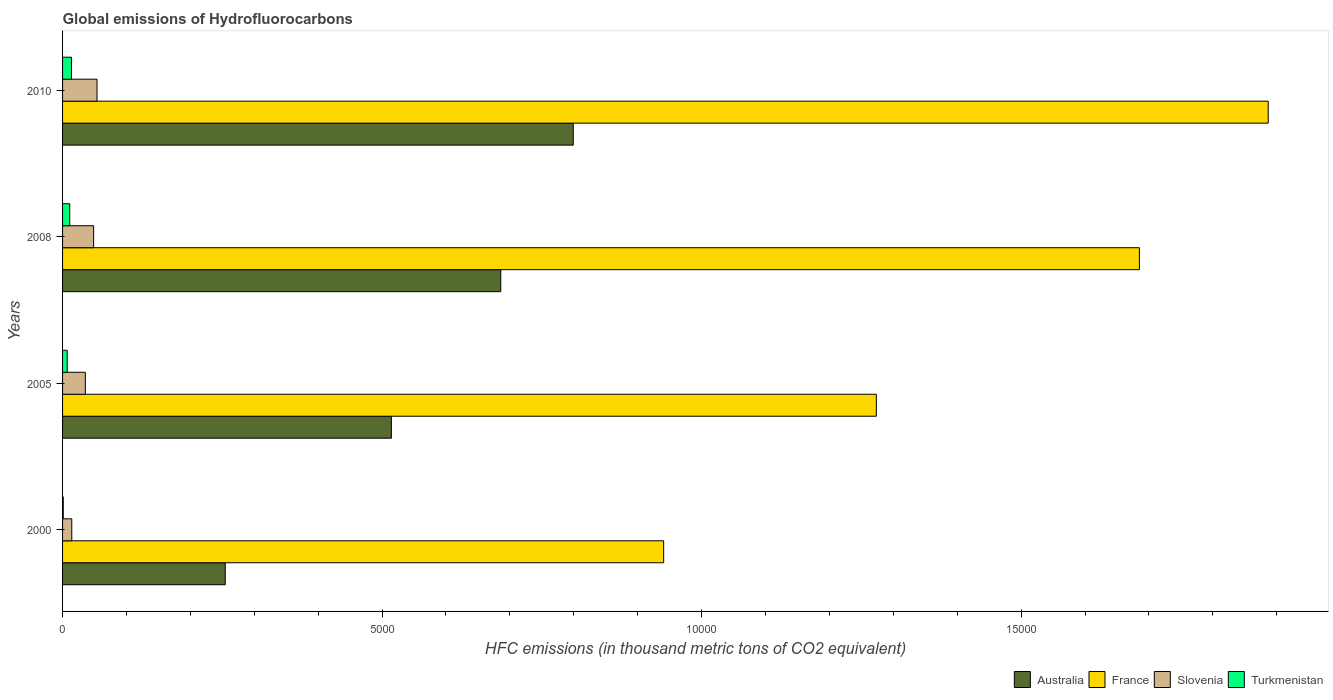Are the number of bars per tick equal to the number of legend labels?
Make the answer very short. Yes. What is the label of the 3rd group of bars from the top?
Provide a short and direct response. 2005. Across all years, what is the maximum global emissions of Hydrofluorocarbons in Australia?
Your answer should be compact. 7992. Across all years, what is the minimum global emissions of Hydrofluorocarbons in Australia?
Provide a short and direct response. 2545.7. In which year was the global emissions of Hydrofluorocarbons in Slovenia maximum?
Provide a succinct answer. 2010. What is the total global emissions of Hydrofluorocarbons in Australia in the graph?
Your answer should be very brief. 2.25e+04. What is the difference between the global emissions of Hydrofluorocarbons in France in 2005 and that in 2008?
Provide a succinct answer. -4116.4. What is the difference between the global emissions of Hydrofluorocarbons in Australia in 2005 and the global emissions of Hydrofluorocarbons in Slovenia in 2008?
Offer a terse response. 4659.6. What is the average global emissions of Hydrofluorocarbons in Australia per year?
Make the answer very short. 5635.18. In the year 2008, what is the difference between the global emissions of Hydrofluorocarbons in Slovenia and global emissions of Hydrofluorocarbons in Turkmenistan?
Ensure brevity in your answer.  373.8. What is the ratio of the global emissions of Hydrofluorocarbons in Turkmenistan in 2005 to that in 2008?
Your answer should be compact. 0.65. Is the difference between the global emissions of Hydrofluorocarbons in Slovenia in 2005 and 2010 greater than the difference between the global emissions of Hydrofluorocarbons in Turkmenistan in 2005 and 2010?
Your response must be concise. No. What is the difference between the highest and the second highest global emissions of Hydrofluorocarbons in France?
Ensure brevity in your answer.  2015.9. What is the difference between the highest and the lowest global emissions of Hydrofluorocarbons in France?
Make the answer very short. 9460.6. What does the 2nd bar from the top in 2010 represents?
Your answer should be very brief. Slovenia. How many bars are there?
Your answer should be very brief. 16. Are all the bars in the graph horizontal?
Your answer should be compact. Yes. How many years are there in the graph?
Provide a short and direct response. 4. What is the difference between two consecutive major ticks on the X-axis?
Offer a terse response. 5000. Are the values on the major ticks of X-axis written in scientific E-notation?
Ensure brevity in your answer.  No. Does the graph contain any zero values?
Ensure brevity in your answer.  No. Does the graph contain grids?
Your answer should be compact. No. How are the legend labels stacked?
Give a very brief answer. Horizontal. What is the title of the graph?
Your response must be concise. Global emissions of Hydrofluorocarbons. Does "East Asia (all income levels)" appear as one of the legend labels in the graph?
Offer a very short reply. No. What is the label or title of the X-axis?
Keep it short and to the point. HFC emissions (in thousand metric tons of CO2 equivalent). What is the HFC emissions (in thousand metric tons of CO2 equivalent) of Australia in 2000?
Provide a short and direct response. 2545.7. What is the HFC emissions (in thousand metric tons of CO2 equivalent) of France in 2000?
Your answer should be very brief. 9406.4. What is the HFC emissions (in thousand metric tons of CO2 equivalent) in Slovenia in 2000?
Provide a short and direct response. 144.1. What is the HFC emissions (in thousand metric tons of CO2 equivalent) in Turkmenistan in 2000?
Your response must be concise. 10.9. What is the HFC emissions (in thousand metric tons of CO2 equivalent) of Australia in 2005?
Give a very brief answer. 5145.6. What is the HFC emissions (in thousand metric tons of CO2 equivalent) of France in 2005?
Make the answer very short. 1.27e+04. What is the HFC emissions (in thousand metric tons of CO2 equivalent) in Slovenia in 2005?
Keep it short and to the point. 356.4. What is the HFC emissions (in thousand metric tons of CO2 equivalent) of Turkmenistan in 2005?
Keep it short and to the point. 72.9. What is the HFC emissions (in thousand metric tons of CO2 equivalent) of Australia in 2008?
Your answer should be very brief. 6857.4. What is the HFC emissions (in thousand metric tons of CO2 equivalent) in France in 2008?
Keep it short and to the point. 1.69e+04. What is the HFC emissions (in thousand metric tons of CO2 equivalent) of Slovenia in 2008?
Keep it short and to the point. 486. What is the HFC emissions (in thousand metric tons of CO2 equivalent) in Turkmenistan in 2008?
Give a very brief answer. 112.2. What is the HFC emissions (in thousand metric tons of CO2 equivalent) of Australia in 2010?
Ensure brevity in your answer.  7992. What is the HFC emissions (in thousand metric tons of CO2 equivalent) in France in 2010?
Provide a short and direct response. 1.89e+04. What is the HFC emissions (in thousand metric tons of CO2 equivalent) in Slovenia in 2010?
Your response must be concise. 539. What is the HFC emissions (in thousand metric tons of CO2 equivalent) in Turkmenistan in 2010?
Give a very brief answer. 139. Across all years, what is the maximum HFC emissions (in thousand metric tons of CO2 equivalent) in Australia?
Make the answer very short. 7992. Across all years, what is the maximum HFC emissions (in thousand metric tons of CO2 equivalent) in France?
Keep it short and to the point. 1.89e+04. Across all years, what is the maximum HFC emissions (in thousand metric tons of CO2 equivalent) of Slovenia?
Offer a very short reply. 539. Across all years, what is the maximum HFC emissions (in thousand metric tons of CO2 equivalent) in Turkmenistan?
Ensure brevity in your answer.  139. Across all years, what is the minimum HFC emissions (in thousand metric tons of CO2 equivalent) of Australia?
Give a very brief answer. 2545.7. Across all years, what is the minimum HFC emissions (in thousand metric tons of CO2 equivalent) in France?
Give a very brief answer. 9406.4. Across all years, what is the minimum HFC emissions (in thousand metric tons of CO2 equivalent) in Slovenia?
Offer a very short reply. 144.1. Across all years, what is the minimum HFC emissions (in thousand metric tons of CO2 equivalent) of Turkmenistan?
Make the answer very short. 10.9. What is the total HFC emissions (in thousand metric tons of CO2 equivalent) of Australia in the graph?
Give a very brief answer. 2.25e+04. What is the total HFC emissions (in thousand metric tons of CO2 equivalent) of France in the graph?
Keep it short and to the point. 5.79e+04. What is the total HFC emissions (in thousand metric tons of CO2 equivalent) of Slovenia in the graph?
Ensure brevity in your answer.  1525.5. What is the total HFC emissions (in thousand metric tons of CO2 equivalent) in Turkmenistan in the graph?
Your response must be concise. 335. What is the difference between the HFC emissions (in thousand metric tons of CO2 equivalent) in Australia in 2000 and that in 2005?
Make the answer very short. -2599.9. What is the difference between the HFC emissions (in thousand metric tons of CO2 equivalent) in France in 2000 and that in 2005?
Make the answer very short. -3328.3. What is the difference between the HFC emissions (in thousand metric tons of CO2 equivalent) of Slovenia in 2000 and that in 2005?
Make the answer very short. -212.3. What is the difference between the HFC emissions (in thousand metric tons of CO2 equivalent) of Turkmenistan in 2000 and that in 2005?
Your response must be concise. -62. What is the difference between the HFC emissions (in thousand metric tons of CO2 equivalent) of Australia in 2000 and that in 2008?
Provide a short and direct response. -4311.7. What is the difference between the HFC emissions (in thousand metric tons of CO2 equivalent) in France in 2000 and that in 2008?
Provide a short and direct response. -7444.7. What is the difference between the HFC emissions (in thousand metric tons of CO2 equivalent) in Slovenia in 2000 and that in 2008?
Make the answer very short. -341.9. What is the difference between the HFC emissions (in thousand metric tons of CO2 equivalent) in Turkmenistan in 2000 and that in 2008?
Offer a very short reply. -101.3. What is the difference between the HFC emissions (in thousand metric tons of CO2 equivalent) of Australia in 2000 and that in 2010?
Ensure brevity in your answer.  -5446.3. What is the difference between the HFC emissions (in thousand metric tons of CO2 equivalent) in France in 2000 and that in 2010?
Offer a very short reply. -9460.6. What is the difference between the HFC emissions (in thousand metric tons of CO2 equivalent) of Slovenia in 2000 and that in 2010?
Your answer should be very brief. -394.9. What is the difference between the HFC emissions (in thousand metric tons of CO2 equivalent) in Turkmenistan in 2000 and that in 2010?
Your answer should be very brief. -128.1. What is the difference between the HFC emissions (in thousand metric tons of CO2 equivalent) of Australia in 2005 and that in 2008?
Your answer should be very brief. -1711.8. What is the difference between the HFC emissions (in thousand metric tons of CO2 equivalent) of France in 2005 and that in 2008?
Ensure brevity in your answer.  -4116.4. What is the difference between the HFC emissions (in thousand metric tons of CO2 equivalent) in Slovenia in 2005 and that in 2008?
Ensure brevity in your answer.  -129.6. What is the difference between the HFC emissions (in thousand metric tons of CO2 equivalent) in Turkmenistan in 2005 and that in 2008?
Ensure brevity in your answer.  -39.3. What is the difference between the HFC emissions (in thousand metric tons of CO2 equivalent) in Australia in 2005 and that in 2010?
Give a very brief answer. -2846.4. What is the difference between the HFC emissions (in thousand metric tons of CO2 equivalent) of France in 2005 and that in 2010?
Provide a succinct answer. -6132.3. What is the difference between the HFC emissions (in thousand metric tons of CO2 equivalent) in Slovenia in 2005 and that in 2010?
Provide a short and direct response. -182.6. What is the difference between the HFC emissions (in thousand metric tons of CO2 equivalent) in Turkmenistan in 2005 and that in 2010?
Keep it short and to the point. -66.1. What is the difference between the HFC emissions (in thousand metric tons of CO2 equivalent) of Australia in 2008 and that in 2010?
Your response must be concise. -1134.6. What is the difference between the HFC emissions (in thousand metric tons of CO2 equivalent) of France in 2008 and that in 2010?
Offer a very short reply. -2015.9. What is the difference between the HFC emissions (in thousand metric tons of CO2 equivalent) of Slovenia in 2008 and that in 2010?
Your answer should be compact. -53. What is the difference between the HFC emissions (in thousand metric tons of CO2 equivalent) of Turkmenistan in 2008 and that in 2010?
Provide a short and direct response. -26.8. What is the difference between the HFC emissions (in thousand metric tons of CO2 equivalent) of Australia in 2000 and the HFC emissions (in thousand metric tons of CO2 equivalent) of France in 2005?
Give a very brief answer. -1.02e+04. What is the difference between the HFC emissions (in thousand metric tons of CO2 equivalent) of Australia in 2000 and the HFC emissions (in thousand metric tons of CO2 equivalent) of Slovenia in 2005?
Your response must be concise. 2189.3. What is the difference between the HFC emissions (in thousand metric tons of CO2 equivalent) of Australia in 2000 and the HFC emissions (in thousand metric tons of CO2 equivalent) of Turkmenistan in 2005?
Offer a very short reply. 2472.8. What is the difference between the HFC emissions (in thousand metric tons of CO2 equivalent) in France in 2000 and the HFC emissions (in thousand metric tons of CO2 equivalent) in Slovenia in 2005?
Your answer should be very brief. 9050. What is the difference between the HFC emissions (in thousand metric tons of CO2 equivalent) of France in 2000 and the HFC emissions (in thousand metric tons of CO2 equivalent) of Turkmenistan in 2005?
Your answer should be compact. 9333.5. What is the difference between the HFC emissions (in thousand metric tons of CO2 equivalent) in Slovenia in 2000 and the HFC emissions (in thousand metric tons of CO2 equivalent) in Turkmenistan in 2005?
Provide a succinct answer. 71.2. What is the difference between the HFC emissions (in thousand metric tons of CO2 equivalent) in Australia in 2000 and the HFC emissions (in thousand metric tons of CO2 equivalent) in France in 2008?
Make the answer very short. -1.43e+04. What is the difference between the HFC emissions (in thousand metric tons of CO2 equivalent) in Australia in 2000 and the HFC emissions (in thousand metric tons of CO2 equivalent) in Slovenia in 2008?
Ensure brevity in your answer.  2059.7. What is the difference between the HFC emissions (in thousand metric tons of CO2 equivalent) in Australia in 2000 and the HFC emissions (in thousand metric tons of CO2 equivalent) in Turkmenistan in 2008?
Your answer should be compact. 2433.5. What is the difference between the HFC emissions (in thousand metric tons of CO2 equivalent) of France in 2000 and the HFC emissions (in thousand metric tons of CO2 equivalent) of Slovenia in 2008?
Provide a short and direct response. 8920.4. What is the difference between the HFC emissions (in thousand metric tons of CO2 equivalent) of France in 2000 and the HFC emissions (in thousand metric tons of CO2 equivalent) of Turkmenistan in 2008?
Provide a succinct answer. 9294.2. What is the difference between the HFC emissions (in thousand metric tons of CO2 equivalent) in Slovenia in 2000 and the HFC emissions (in thousand metric tons of CO2 equivalent) in Turkmenistan in 2008?
Your answer should be compact. 31.9. What is the difference between the HFC emissions (in thousand metric tons of CO2 equivalent) of Australia in 2000 and the HFC emissions (in thousand metric tons of CO2 equivalent) of France in 2010?
Your response must be concise. -1.63e+04. What is the difference between the HFC emissions (in thousand metric tons of CO2 equivalent) of Australia in 2000 and the HFC emissions (in thousand metric tons of CO2 equivalent) of Slovenia in 2010?
Your response must be concise. 2006.7. What is the difference between the HFC emissions (in thousand metric tons of CO2 equivalent) in Australia in 2000 and the HFC emissions (in thousand metric tons of CO2 equivalent) in Turkmenistan in 2010?
Provide a succinct answer. 2406.7. What is the difference between the HFC emissions (in thousand metric tons of CO2 equivalent) of France in 2000 and the HFC emissions (in thousand metric tons of CO2 equivalent) of Slovenia in 2010?
Keep it short and to the point. 8867.4. What is the difference between the HFC emissions (in thousand metric tons of CO2 equivalent) of France in 2000 and the HFC emissions (in thousand metric tons of CO2 equivalent) of Turkmenistan in 2010?
Keep it short and to the point. 9267.4. What is the difference between the HFC emissions (in thousand metric tons of CO2 equivalent) of Australia in 2005 and the HFC emissions (in thousand metric tons of CO2 equivalent) of France in 2008?
Offer a very short reply. -1.17e+04. What is the difference between the HFC emissions (in thousand metric tons of CO2 equivalent) of Australia in 2005 and the HFC emissions (in thousand metric tons of CO2 equivalent) of Slovenia in 2008?
Give a very brief answer. 4659.6. What is the difference between the HFC emissions (in thousand metric tons of CO2 equivalent) in Australia in 2005 and the HFC emissions (in thousand metric tons of CO2 equivalent) in Turkmenistan in 2008?
Your answer should be compact. 5033.4. What is the difference between the HFC emissions (in thousand metric tons of CO2 equivalent) of France in 2005 and the HFC emissions (in thousand metric tons of CO2 equivalent) of Slovenia in 2008?
Offer a terse response. 1.22e+04. What is the difference between the HFC emissions (in thousand metric tons of CO2 equivalent) in France in 2005 and the HFC emissions (in thousand metric tons of CO2 equivalent) in Turkmenistan in 2008?
Provide a succinct answer. 1.26e+04. What is the difference between the HFC emissions (in thousand metric tons of CO2 equivalent) in Slovenia in 2005 and the HFC emissions (in thousand metric tons of CO2 equivalent) in Turkmenistan in 2008?
Give a very brief answer. 244.2. What is the difference between the HFC emissions (in thousand metric tons of CO2 equivalent) in Australia in 2005 and the HFC emissions (in thousand metric tons of CO2 equivalent) in France in 2010?
Keep it short and to the point. -1.37e+04. What is the difference between the HFC emissions (in thousand metric tons of CO2 equivalent) in Australia in 2005 and the HFC emissions (in thousand metric tons of CO2 equivalent) in Slovenia in 2010?
Make the answer very short. 4606.6. What is the difference between the HFC emissions (in thousand metric tons of CO2 equivalent) in Australia in 2005 and the HFC emissions (in thousand metric tons of CO2 equivalent) in Turkmenistan in 2010?
Provide a succinct answer. 5006.6. What is the difference between the HFC emissions (in thousand metric tons of CO2 equivalent) of France in 2005 and the HFC emissions (in thousand metric tons of CO2 equivalent) of Slovenia in 2010?
Make the answer very short. 1.22e+04. What is the difference between the HFC emissions (in thousand metric tons of CO2 equivalent) in France in 2005 and the HFC emissions (in thousand metric tons of CO2 equivalent) in Turkmenistan in 2010?
Your response must be concise. 1.26e+04. What is the difference between the HFC emissions (in thousand metric tons of CO2 equivalent) in Slovenia in 2005 and the HFC emissions (in thousand metric tons of CO2 equivalent) in Turkmenistan in 2010?
Offer a very short reply. 217.4. What is the difference between the HFC emissions (in thousand metric tons of CO2 equivalent) of Australia in 2008 and the HFC emissions (in thousand metric tons of CO2 equivalent) of France in 2010?
Give a very brief answer. -1.20e+04. What is the difference between the HFC emissions (in thousand metric tons of CO2 equivalent) in Australia in 2008 and the HFC emissions (in thousand metric tons of CO2 equivalent) in Slovenia in 2010?
Keep it short and to the point. 6318.4. What is the difference between the HFC emissions (in thousand metric tons of CO2 equivalent) of Australia in 2008 and the HFC emissions (in thousand metric tons of CO2 equivalent) of Turkmenistan in 2010?
Your answer should be very brief. 6718.4. What is the difference between the HFC emissions (in thousand metric tons of CO2 equivalent) in France in 2008 and the HFC emissions (in thousand metric tons of CO2 equivalent) in Slovenia in 2010?
Provide a succinct answer. 1.63e+04. What is the difference between the HFC emissions (in thousand metric tons of CO2 equivalent) in France in 2008 and the HFC emissions (in thousand metric tons of CO2 equivalent) in Turkmenistan in 2010?
Keep it short and to the point. 1.67e+04. What is the difference between the HFC emissions (in thousand metric tons of CO2 equivalent) in Slovenia in 2008 and the HFC emissions (in thousand metric tons of CO2 equivalent) in Turkmenistan in 2010?
Offer a very short reply. 347. What is the average HFC emissions (in thousand metric tons of CO2 equivalent) of Australia per year?
Provide a succinct answer. 5635.18. What is the average HFC emissions (in thousand metric tons of CO2 equivalent) of France per year?
Give a very brief answer. 1.45e+04. What is the average HFC emissions (in thousand metric tons of CO2 equivalent) of Slovenia per year?
Provide a succinct answer. 381.38. What is the average HFC emissions (in thousand metric tons of CO2 equivalent) in Turkmenistan per year?
Provide a short and direct response. 83.75. In the year 2000, what is the difference between the HFC emissions (in thousand metric tons of CO2 equivalent) of Australia and HFC emissions (in thousand metric tons of CO2 equivalent) of France?
Keep it short and to the point. -6860.7. In the year 2000, what is the difference between the HFC emissions (in thousand metric tons of CO2 equivalent) in Australia and HFC emissions (in thousand metric tons of CO2 equivalent) in Slovenia?
Offer a terse response. 2401.6. In the year 2000, what is the difference between the HFC emissions (in thousand metric tons of CO2 equivalent) in Australia and HFC emissions (in thousand metric tons of CO2 equivalent) in Turkmenistan?
Your response must be concise. 2534.8. In the year 2000, what is the difference between the HFC emissions (in thousand metric tons of CO2 equivalent) in France and HFC emissions (in thousand metric tons of CO2 equivalent) in Slovenia?
Your answer should be compact. 9262.3. In the year 2000, what is the difference between the HFC emissions (in thousand metric tons of CO2 equivalent) in France and HFC emissions (in thousand metric tons of CO2 equivalent) in Turkmenistan?
Your response must be concise. 9395.5. In the year 2000, what is the difference between the HFC emissions (in thousand metric tons of CO2 equivalent) in Slovenia and HFC emissions (in thousand metric tons of CO2 equivalent) in Turkmenistan?
Provide a succinct answer. 133.2. In the year 2005, what is the difference between the HFC emissions (in thousand metric tons of CO2 equivalent) of Australia and HFC emissions (in thousand metric tons of CO2 equivalent) of France?
Your answer should be very brief. -7589.1. In the year 2005, what is the difference between the HFC emissions (in thousand metric tons of CO2 equivalent) of Australia and HFC emissions (in thousand metric tons of CO2 equivalent) of Slovenia?
Your response must be concise. 4789.2. In the year 2005, what is the difference between the HFC emissions (in thousand metric tons of CO2 equivalent) of Australia and HFC emissions (in thousand metric tons of CO2 equivalent) of Turkmenistan?
Offer a terse response. 5072.7. In the year 2005, what is the difference between the HFC emissions (in thousand metric tons of CO2 equivalent) in France and HFC emissions (in thousand metric tons of CO2 equivalent) in Slovenia?
Give a very brief answer. 1.24e+04. In the year 2005, what is the difference between the HFC emissions (in thousand metric tons of CO2 equivalent) in France and HFC emissions (in thousand metric tons of CO2 equivalent) in Turkmenistan?
Your answer should be compact. 1.27e+04. In the year 2005, what is the difference between the HFC emissions (in thousand metric tons of CO2 equivalent) in Slovenia and HFC emissions (in thousand metric tons of CO2 equivalent) in Turkmenistan?
Keep it short and to the point. 283.5. In the year 2008, what is the difference between the HFC emissions (in thousand metric tons of CO2 equivalent) in Australia and HFC emissions (in thousand metric tons of CO2 equivalent) in France?
Offer a very short reply. -9993.7. In the year 2008, what is the difference between the HFC emissions (in thousand metric tons of CO2 equivalent) in Australia and HFC emissions (in thousand metric tons of CO2 equivalent) in Slovenia?
Give a very brief answer. 6371.4. In the year 2008, what is the difference between the HFC emissions (in thousand metric tons of CO2 equivalent) of Australia and HFC emissions (in thousand metric tons of CO2 equivalent) of Turkmenistan?
Ensure brevity in your answer.  6745.2. In the year 2008, what is the difference between the HFC emissions (in thousand metric tons of CO2 equivalent) in France and HFC emissions (in thousand metric tons of CO2 equivalent) in Slovenia?
Make the answer very short. 1.64e+04. In the year 2008, what is the difference between the HFC emissions (in thousand metric tons of CO2 equivalent) in France and HFC emissions (in thousand metric tons of CO2 equivalent) in Turkmenistan?
Keep it short and to the point. 1.67e+04. In the year 2008, what is the difference between the HFC emissions (in thousand metric tons of CO2 equivalent) of Slovenia and HFC emissions (in thousand metric tons of CO2 equivalent) of Turkmenistan?
Provide a succinct answer. 373.8. In the year 2010, what is the difference between the HFC emissions (in thousand metric tons of CO2 equivalent) in Australia and HFC emissions (in thousand metric tons of CO2 equivalent) in France?
Keep it short and to the point. -1.09e+04. In the year 2010, what is the difference between the HFC emissions (in thousand metric tons of CO2 equivalent) of Australia and HFC emissions (in thousand metric tons of CO2 equivalent) of Slovenia?
Ensure brevity in your answer.  7453. In the year 2010, what is the difference between the HFC emissions (in thousand metric tons of CO2 equivalent) in Australia and HFC emissions (in thousand metric tons of CO2 equivalent) in Turkmenistan?
Provide a succinct answer. 7853. In the year 2010, what is the difference between the HFC emissions (in thousand metric tons of CO2 equivalent) of France and HFC emissions (in thousand metric tons of CO2 equivalent) of Slovenia?
Offer a very short reply. 1.83e+04. In the year 2010, what is the difference between the HFC emissions (in thousand metric tons of CO2 equivalent) in France and HFC emissions (in thousand metric tons of CO2 equivalent) in Turkmenistan?
Make the answer very short. 1.87e+04. What is the ratio of the HFC emissions (in thousand metric tons of CO2 equivalent) in Australia in 2000 to that in 2005?
Keep it short and to the point. 0.49. What is the ratio of the HFC emissions (in thousand metric tons of CO2 equivalent) of France in 2000 to that in 2005?
Keep it short and to the point. 0.74. What is the ratio of the HFC emissions (in thousand metric tons of CO2 equivalent) of Slovenia in 2000 to that in 2005?
Offer a terse response. 0.4. What is the ratio of the HFC emissions (in thousand metric tons of CO2 equivalent) in Turkmenistan in 2000 to that in 2005?
Offer a terse response. 0.15. What is the ratio of the HFC emissions (in thousand metric tons of CO2 equivalent) in Australia in 2000 to that in 2008?
Make the answer very short. 0.37. What is the ratio of the HFC emissions (in thousand metric tons of CO2 equivalent) in France in 2000 to that in 2008?
Your answer should be compact. 0.56. What is the ratio of the HFC emissions (in thousand metric tons of CO2 equivalent) of Slovenia in 2000 to that in 2008?
Make the answer very short. 0.3. What is the ratio of the HFC emissions (in thousand metric tons of CO2 equivalent) in Turkmenistan in 2000 to that in 2008?
Your answer should be compact. 0.1. What is the ratio of the HFC emissions (in thousand metric tons of CO2 equivalent) in Australia in 2000 to that in 2010?
Ensure brevity in your answer.  0.32. What is the ratio of the HFC emissions (in thousand metric tons of CO2 equivalent) of France in 2000 to that in 2010?
Provide a short and direct response. 0.5. What is the ratio of the HFC emissions (in thousand metric tons of CO2 equivalent) of Slovenia in 2000 to that in 2010?
Provide a short and direct response. 0.27. What is the ratio of the HFC emissions (in thousand metric tons of CO2 equivalent) of Turkmenistan in 2000 to that in 2010?
Keep it short and to the point. 0.08. What is the ratio of the HFC emissions (in thousand metric tons of CO2 equivalent) of Australia in 2005 to that in 2008?
Offer a very short reply. 0.75. What is the ratio of the HFC emissions (in thousand metric tons of CO2 equivalent) of France in 2005 to that in 2008?
Make the answer very short. 0.76. What is the ratio of the HFC emissions (in thousand metric tons of CO2 equivalent) of Slovenia in 2005 to that in 2008?
Your answer should be very brief. 0.73. What is the ratio of the HFC emissions (in thousand metric tons of CO2 equivalent) in Turkmenistan in 2005 to that in 2008?
Offer a very short reply. 0.65. What is the ratio of the HFC emissions (in thousand metric tons of CO2 equivalent) of Australia in 2005 to that in 2010?
Keep it short and to the point. 0.64. What is the ratio of the HFC emissions (in thousand metric tons of CO2 equivalent) of France in 2005 to that in 2010?
Keep it short and to the point. 0.68. What is the ratio of the HFC emissions (in thousand metric tons of CO2 equivalent) of Slovenia in 2005 to that in 2010?
Offer a terse response. 0.66. What is the ratio of the HFC emissions (in thousand metric tons of CO2 equivalent) of Turkmenistan in 2005 to that in 2010?
Offer a terse response. 0.52. What is the ratio of the HFC emissions (in thousand metric tons of CO2 equivalent) of Australia in 2008 to that in 2010?
Make the answer very short. 0.86. What is the ratio of the HFC emissions (in thousand metric tons of CO2 equivalent) in France in 2008 to that in 2010?
Keep it short and to the point. 0.89. What is the ratio of the HFC emissions (in thousand metric tons of CO2 equivalent) of Slovenia in 2008 to that in 2010?
Offer a very short reply. 0.9. What is the ratio of the HFC emissions (in thousand metric tons of CO2 equivalent) of Turkmenistan in 2008 to that in 2010?
Give a very brief answer. 0.81. What is the difference between the highest and the second highest HFC emissions (in thousand metric tons of CO2 equivalent) of Australia?
Your answer should be compact. 1134.6. What is the difference between the highest and the second highest HFC emissions (in thousand metric tons of CO2 equivalent) of France?
Provide a short and direct response. 2015.9. What is the difference between the highest and the second highest HFC emissions (in thousand metric tons of CO2 equivalent) of Turkmenistan?
Provide a succinct answer. 26.8. What is the difference between the highest and the lowest HFC emissions (in thousand metric tons of CO2 equivalent) in Australia?
Offer a terse response. 5446.3. What is the difference between the highest and the lowest HFC emissions (in thousand metric tons of CO2 equivalent) in France?
Your answer should be very brief. 9460.6. What is the difference between the highest and the lowest HFC emissions (in thousand metric tons of CO2 equivalent) of Slovenia?
Make the answer very short. 394.9. What is the difference between the highest and the lowest HFC emissions (in thousand metric tons of CO2 equivalent) of Turkmenistan?
Ensure brevity in your answer.  128.1. 